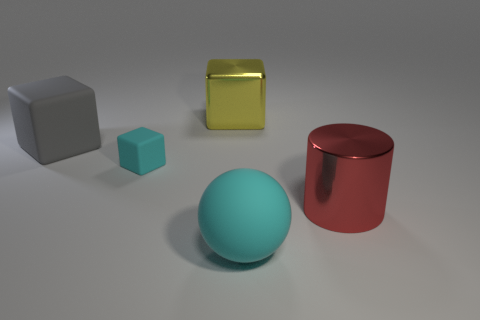Add 3 large rubber cubes. How many objects exist? 8 Subtract all cylinders. How many objects are left? 4 Add 1 large brown things. How many large brown things exist? 1 Subtract 0 cyan cylinders. How many objects are left? 5 Subtract all tiny cyan cylinders. Subtract all big gray matte cubes. How many objects are left? 4 Add 3 big cylinders. How many big cylinders are left? 4 